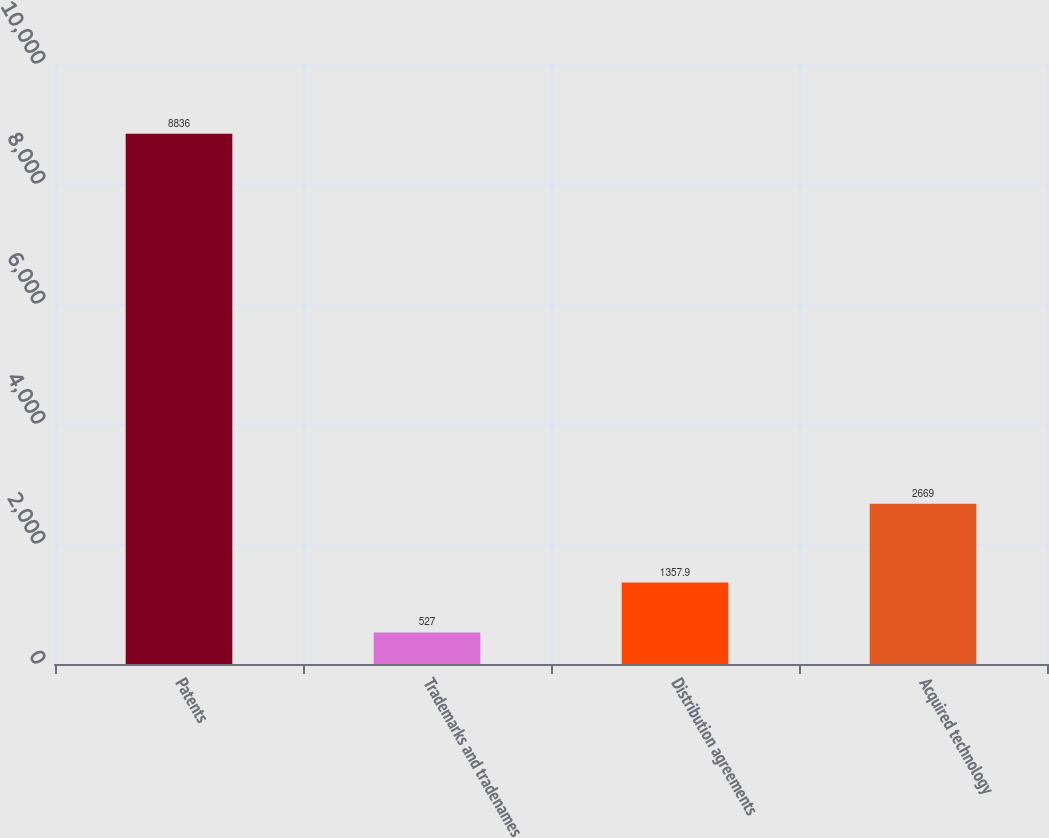Convert chart. <chart><loc_0><loc_0><loc_500><loc_500><bar_chart><fcel>Patents<fcel>Trademarks and tradenames<fcel>Distribution agreements<fcel>Acquired technology<nl><fcel>8836<fcel>527<fcel>1357.9<fcel>2669<nl></chart> 